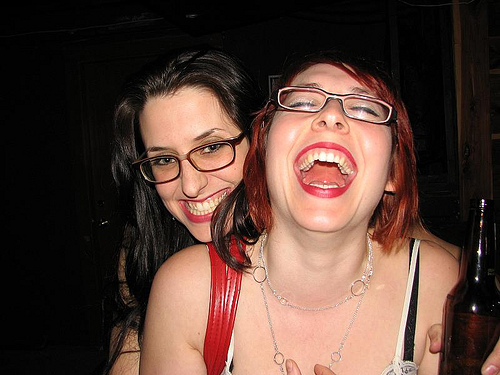<image>
Is there a girl in the girl? No. The girl is not contained within the girl. These objects have a different spatial relationship. 